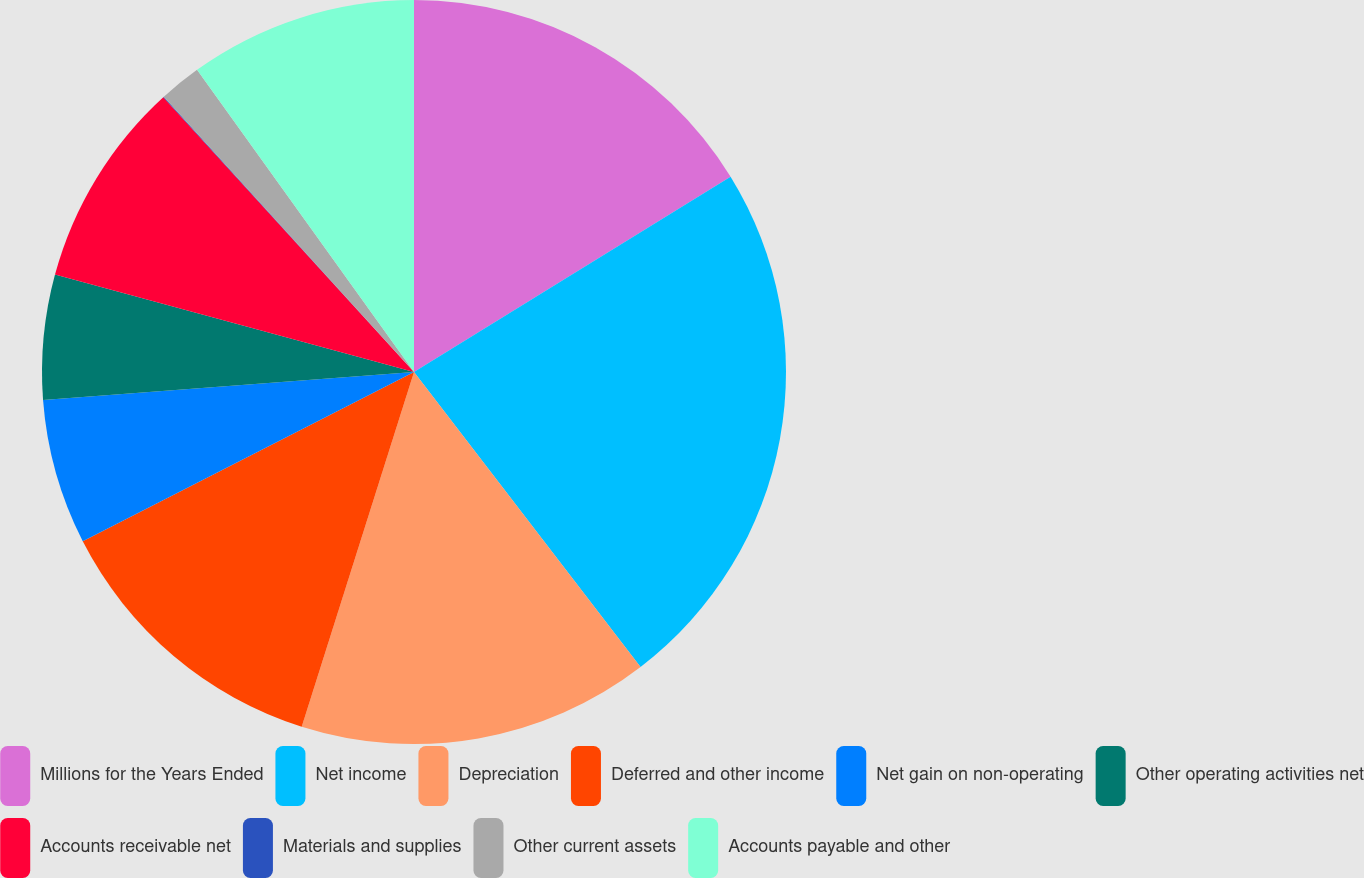<chart> <loc_0><loc_0><loc_500><loc_500><pie_chart><fcel>Millions for the Years Ended<fcel>Net income<fcel>Depreciation<fcel>Deferred and other income<fcel>Net gain on non-operating<fcel>Other operating activities net<fcel>Accounts receivable net<fcel>Materials and supplies<fcel>Other current assets<fcel>Accounts payable and other<nl><fcel>16.2%<fcel>23.38%<fcel>15.3%<fcel>12.6%<fcel>6.32%<fcel>5.42%<fcel>9.01%<fcel>0.03%<fcel>1.83%<fcel>9.91%<nl></chart> 